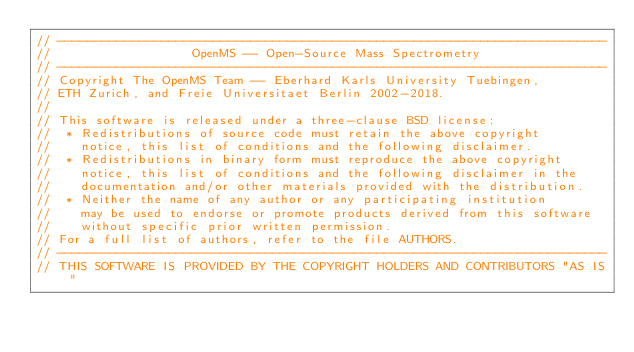Convert code to text. <code><loc_0><loc_0><loc_500><loc_500><_C++_>// --------------------------------------------------------------------------
//                   OpenMS -- Open-Source Mass Spectrometry
// --------------------------------------------------------------------------
// Copyright The OpenMS Team -- Eberhard Karls University Tuebingen,
// ETH Zurich, and Freie Universitaet Berlin 2002-2018.
//
// This software is released under a three-clause BSD license:
//  * Redistributions of source code must retain the above copyright
//    notice, this list of conditions and the following disclaimer.
//  * Redistributions in binary form must reproduce the above copyright
//    notice, this list of conditions and the following disclaimer in the
//    documentation and/or other materials provided with the distribution.
//  * Neither the name of any author or any participating institution
//    may be used to endorse or promote products derived from this software
//    without specific prior written permission.
// For a full list of authors, refer to the file AUTHORS.
// --------------------------------------------------------------------------
// THIS SOFTWARE IS PROVIDED BY THE COPYRIGHT HOLDERS AND CONTRIBUTORS "AS IS"</code> 